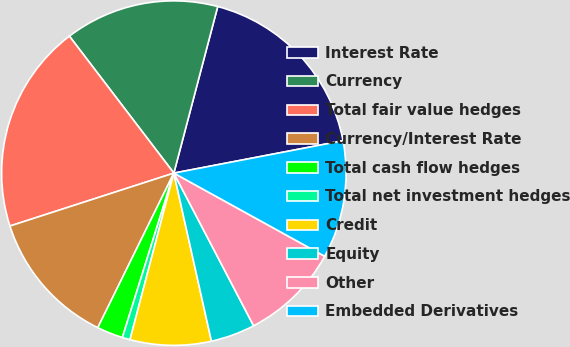Convert chart. <chart><loc_0><loc_0><loc_500><loc_500><pie_chart><fcel>Interest Rate<fcel>Currency<fcel>Total fair value hedges<fcel>Currency/Interest Rate<fcel>Total cash flow hedges<fcel>Total net investment hedges<fcel>Credit<fcel>Equity<fcel>Other<fcel>Embedded Derivatives<nl><fcel>17.89%<fcel>14.47%<fcel>19.6%<fcel>12.75%<fcel>2.45%<fcel>0.73%<fcel>7.6%<fcel>4.16%<fcel>9.32%<fcel>11.03%<nl></chart> 